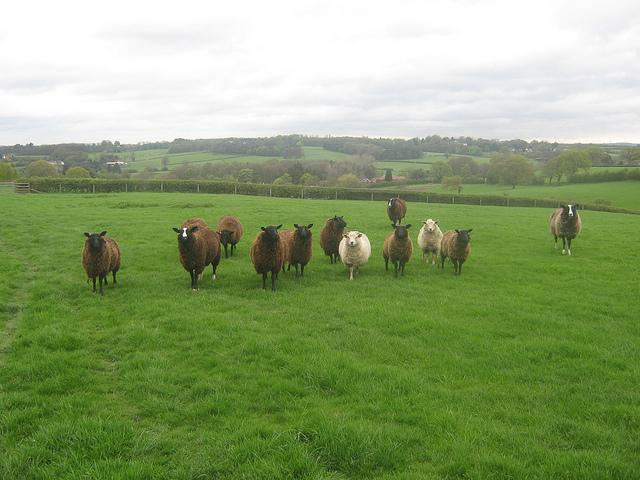What color sheep are there more of?
Keep it brief. Brown. How many of them are white?
Answer briefly. 2. Is there a sheepdog in the picture?
Give a very brief answer. No. 